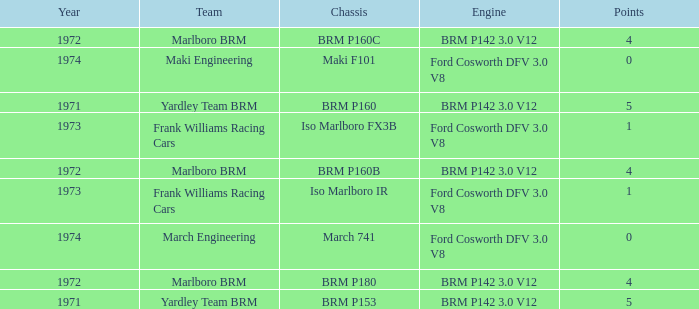Which chassis has marlboro brm as the team? BRM P160B, BRM P180, BRM P160C. 